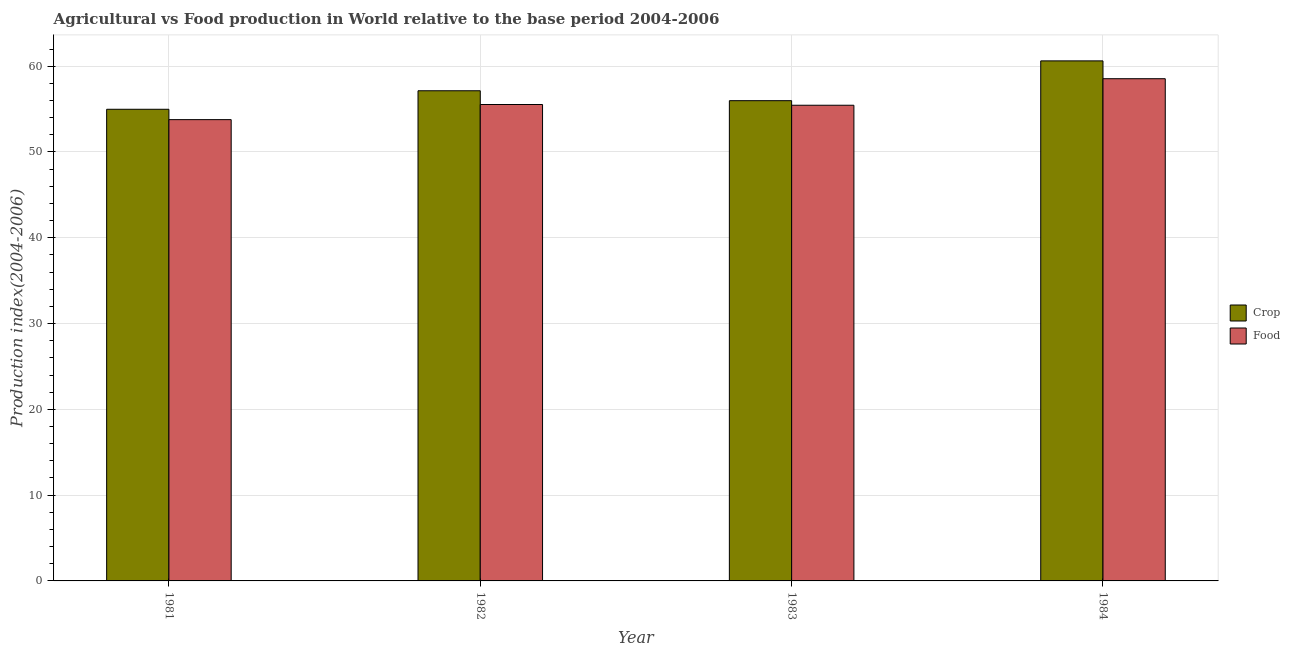How many different coloured bars are there?
Offer a very short reply. 2. How many bars are there on the 2nd tick from the left?
Provide a short and direct response. 2. How many bars are there on the 2nd tick from the right?
Provide a succinct answer. 2. In how many cases, is the number of bars for a given year not equal to the number of legend labels?
Offer a terse response. 0. What is the food production index in 1984?
Provide a succinct answer. 58.54. Across all years, what is the maximum crop production index?
Provide a succinct answer. 60.62. Across all years, what is the minimum food production index?
Provide a short and direct response. 53.77. In which year was the crop production index minimum?
Ensure brevity in your answer.  1981. What is the total crop production index in the graph?
Give a very brief answer. 228.71. What is the difference between the crop production index in 1981 and that in 1984?
Provide a succinct answer. -5.64. What is the difference between the food production index in 1981 and the crop production index in 1982?
Make the answer very short. -1.76. What is the average crop production index per year?
Offer a very short reply. 57.18. In the year 1984, what is the difference between the crop production index and food production index?
Offer a very short reply. 0. In how many years, is the food production index greater than 46?
Your answer should be very brief. 4. What is the ratio of the crop production index in 1982 to that in 1984?
Your response must be concise. 0.94. Is the food production index in 1981 less than that in 1984?
Provide a succinct answer. Yes. Is the difference between the food production index in 1981 and 1984 greater than the difference between the crop production index in 1981 and 1984?
Offer a terse response. No. What is the difference between the highest and the second highest crop production index?
Provide a short and direct response. 3.48. What is the difference between the highest and the lowest crop production index?
Your response must be concise. 5.64. In how many years, is the food production index greater than the average food production index taken over all years?
Provide a succinct answer. 1. What does the 2nd bar from the left in 1981 represents?
Keep it short and to the point. Food. What does the 1st bar from the right in 1981 represents?
Offer a very short reply. Food. Are the values on the major ticks of Y-axis written in scientific E-notation?
Offer a very short reply. No. Does the graph contain any zero values?
Give a very brief answer. No. Does the graph contain grids?
Provide a succinct answer. Yes. Where does the legend appear in the graph?
Your response must be concise. Center right. How many legend labels are there?
Your answer should be very brief. 2. How are the legend labels stacked?
Give a very brief answer. Vertical. What is the title of the graph?
Offer a very short reply. Agricultural vs Food production in World relative to the base period 2004-2006. What is the label or title of the X-axis?
Provide a succinct answer. Year. What is the label or title of the Y-axis?
Offer a very short reply. Production index(2004-2006). What is the Production index(2004-2006) of Crop in 1981?
Provide a short and direct response. 54.98. What is the Production index(2004-2006) in Food in 1981?
Offer a very short reply. 53.77. What is the Production index(2004-2006) in Crop in 1982?
Provide a short and direct response. 57.14. What is the Production index(2004-2006) of Food in 1982?
Give a very brief answer. 55.53. What is the Production index(2004-2006) in Crop in 1983?
Provide a succinct answer. 55.98. What is the Production index(2004-2006) in Food in 1983?
Ensure brevity in your answer.  55.45. What is the Production index(2004-2006) of Crop in 1984?
Provide a short and direct response. 60.62. What is the Production index(2004-2006) in Food in 1984?
Make the answer very short. 58.54. Across all years, what is the maximum Production index(2004-2006) of Crop?
Give a very brief answer. 60.62. Across all years, what is the maximum Production index(2004-2006) in Food?
Offer a very short reply. 58.54. Across all years, what is the minimum Production index(2004-2006) in Crop?
Give a very brief answer. 54.98. Across all years, what is the minimum Production index(2004-2006) of Food?
Offer a very short reply. 53.77. What is the total Production index(2004-2006) in Crop in the graph?
Your response must be concise. 228.71. What is the total Production index(2004-2006) in Food in the graph?
Make the answer very short. 223.29. What is the difference between the Production index(2004-2006) in Crop in 1981 and that in 1982?
Provide a succinct answer. -2.16. What is the difference between the Production index(2004-2006) in Food in 1981 and that in 1982?
Offer a terse response. -1.76. What is the difference between the Production index(2004-2006) of Crop in 1981 and that in 1983?
Your answer should be very brief. -1. What is the difference between the Production index(2004-2006) of Food in 1981 and that in 1983?
Make the answer very short. -1.68. What is the difference between the Production index(2004-2006) in Crop in 1981 and that in 1984?
Offer a terse response. -5.64. What is the difference between the Production index(2004-2006) in Food in 1981 and that in 1984?
Make the answer very short. -4.77. What is the difference between the Production index(2004-2006) in Crop in 1982 and that in 1983?
Give a very brief answer. 1.16. What is the difference between the Production index(2004-2006) in Food in 1982 and that in 1983?
Offer a terse response. 0.09. What is the difference between the Production index(2004-2006) of Crop in 1982 and that in 1984?
Offer a terse response. -3.48. What is the difference between the Production index(2004-2006) of Food in 1982 and that in 1984?
Your answer should be very brief. -3.01. What is the difference between the Production index(2004-2006) of Crop in 1983 and that in 1984?
Provide a short and direct response. -4.64. What is the difference between the Production index(2004-2006) in Food in 1983 and that in 1984?
Ensure brevity in your answer.  -3.09. What is the difference between the Production index(2004-2006) in Crop in 1981 and the Production index(2004-2006) in Food in 1982?
Ensure brevity in your answer.  -0.56. What is the difference between the Production index(2004-2006) in Crop in 1981 and the Production index(2004-2006) in Food in 1983?
Give a very brief answer. -0.47. What is the difference between the Production index(2004-2006) of Crop in 1981 and the Production index(2004-2006) of Food in 1984?
Your answer should be compact. -3.56. What is the difference between the Production index(2004-2006) of Crop in 1982 and the Production index(2004-2006) of Food in 1983?
Ensure brevity in your answer.  1.69. What is the difference between the Production index(2004-2006) of Crop in 1982 and the Production index(2004-2006) of Food in 1984?
Your answer should be very brief. -1.4. What is the difference between the Production index(2004-2006) of Crop in 1983 and the Production index(2004-2006) of Food in 1984?
Give a very brief answer. -2.56. What is the average Production index(2004-2006) in Crop per year?
Ensure brevity in your answer.  57.18. What is the average Production index(2004-2006) in Food per year?
Your answer should be very brief. 55.82. In the year 1981, what is the difference between the Production index(2004-2006) of Crop and Production index(2004-2006) of Food?
Your answer should be very brief. 1.21. In the year 1982, what is the difference between the Production index(2004-2006) in Crop and Production index(2004-2006) in Food?
Keep it short and to the point. 1.6. In the year 1983, what is the difference between the Production index(2004-2006) in Crop and Production index(2004-2006) in Food?
Give a very brief answer. 0.53. In the year 1984, what is the difference between the Production index(2004-2006) in Crop and Production index(2004-2006) in Food?
Keep it short and to the point. 2.08. What is the ratio of the Production index(2004-2006) in Crop in 1981 to that in 1982?
Keep it short and to the point. 0.96. What is the ratio of the Production index(2004-2006) in Food in 1981 to that in 1982?
Your answer should be very brief. 0.97. What is the ratio of the Production index(2004-2006) in Crop in 1981 to that in 1983?
Your answer should be compact. 0.98. What is the ratio of the Production index(2004-2006) of Food in 1981 to that in 1983?
Your answer should be compact. 0.97. What is the ratio of the Production index(2004-2006) of Crop in 1981 to that in 1984?
Ensure brevity in your answer.  0.91. What is the ratio of the Production index(2004-2006) in Food in 1981 to that in 1984?
Offer a terse response. 0.92. What is the ratio of the Production index(2004-2006) of Crop in 1982 to that in 1983?
Ensure brevity in your answer.  1.02. What is the ratio of the Production index(2004-2006) in Crop in 1982 to that in 1984?
Give a very brief answer. 0.94. What is the ratio of the Production index(2004-2006) of Food in 1982 to that in 1984?
Your response must be concise. 0.95. What is the ratio of the Production index(2004-2006) of Crop in 1983 to that in 1984?
Offer a terse response. 0.92. What is the ratio of the Production index(2004-2006) of Food in 1983 to that in 1984?
Make the answer very short. 0.95. What is the difference between the highest and the second highest Production index(2004-2006) in Crop?
Give a very brief answer. 3.48. What is the difference between the highest and the second highest Production index(2004-2006) of Food?
Make the answer very short. 3.01. What is the difference between the highest and the lowest Production index(2004-2006) in Crop?
Your answer should be compact. 5.64. What is the difference between the highest and the lowest Production index(2004-2006) of Food?
Offer a terse response. 4.77. 